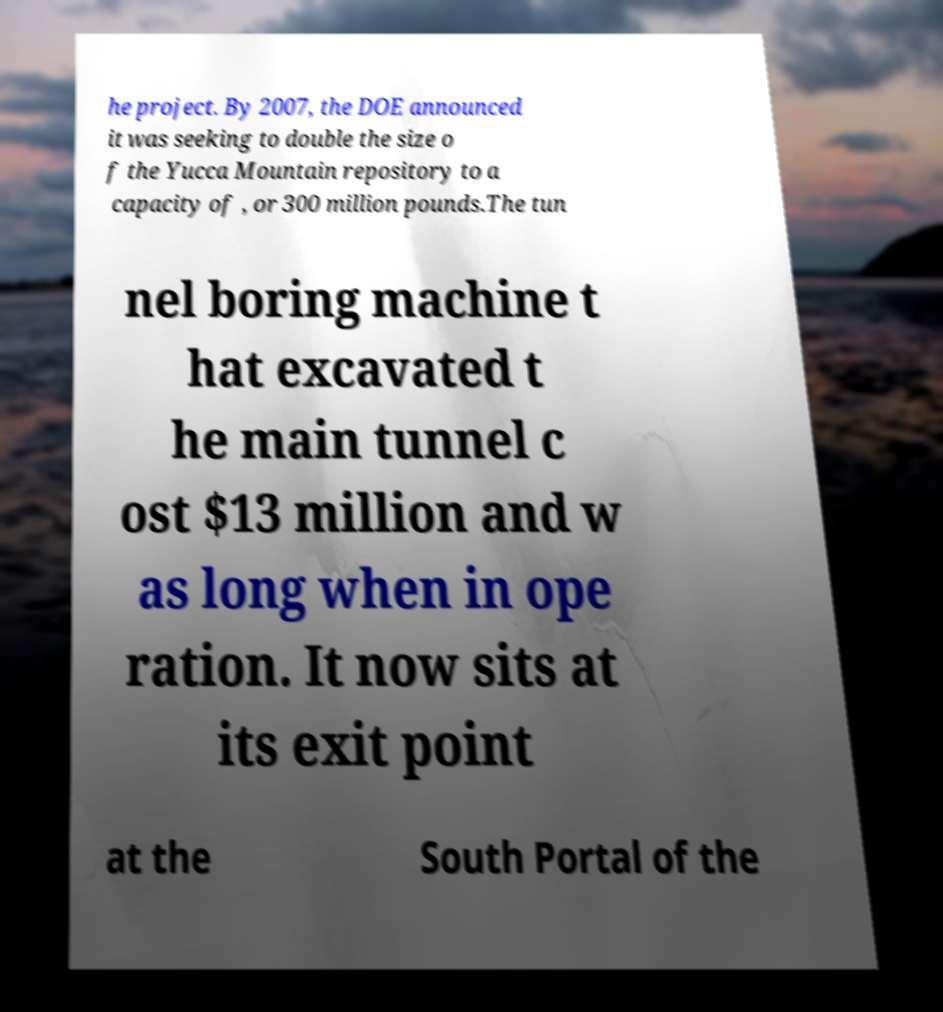Please identify and transcribe the text found in this image. he project. By 2007, the DOE announced it was seeking to double the size o f the Yucca Mountain repository to a capacity of , or 300 million pounds.The tun nel boring machine t hat excavated t he main tunnel c ost $13 million and w as long when in ope ration. It now sits at its exit point at the South Portal of the 